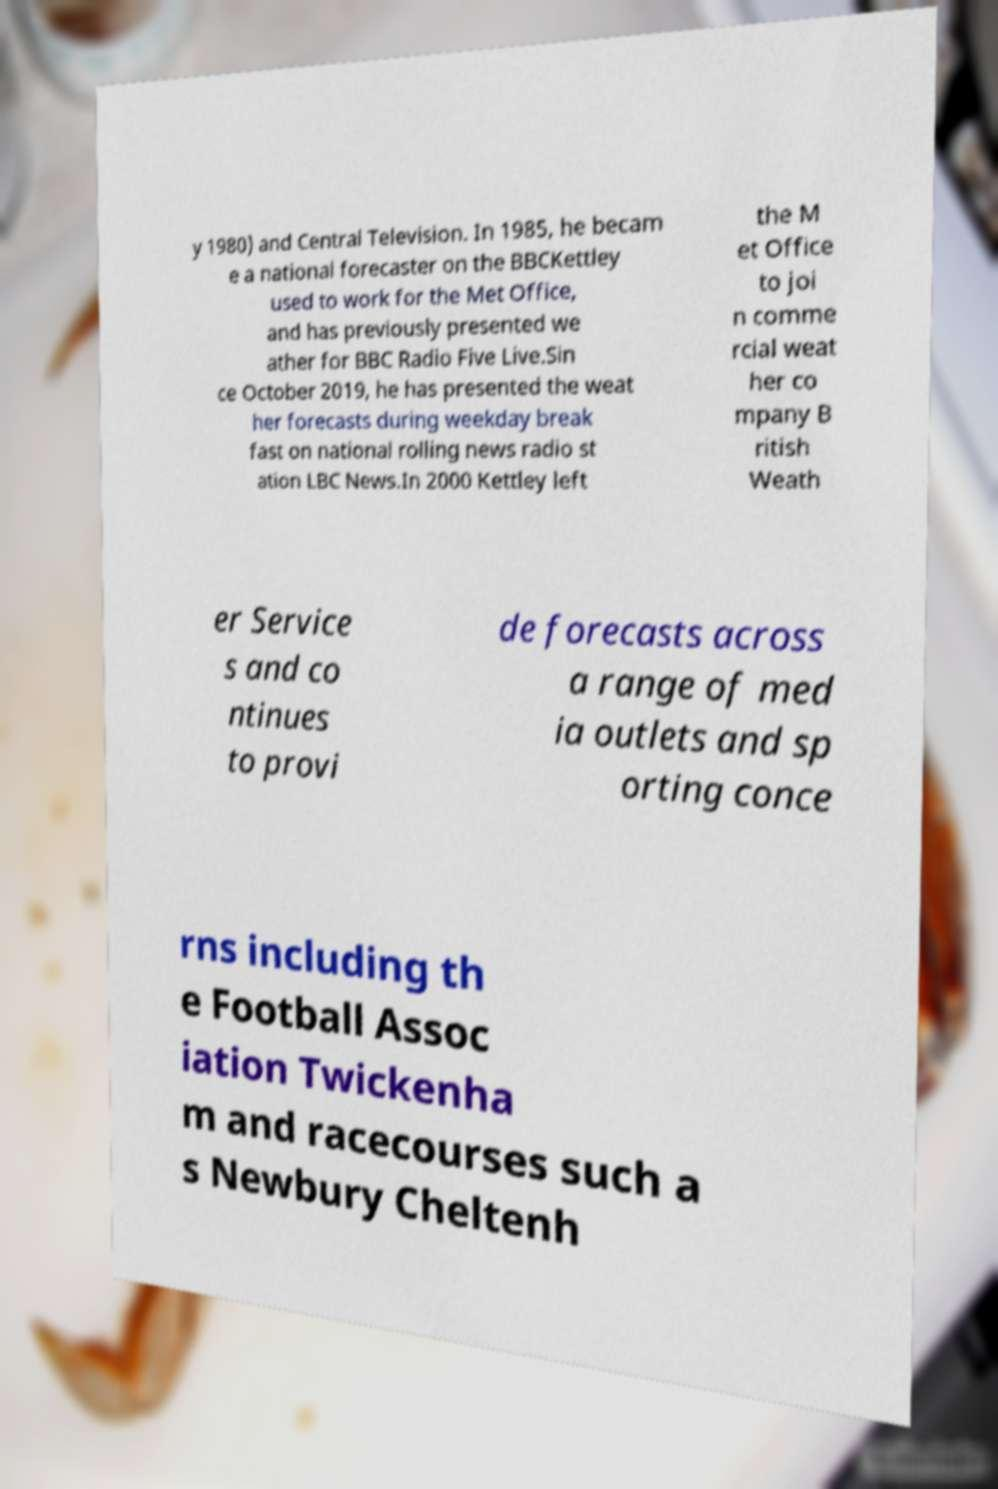Could you extract and type out the text from this image? y 1980) and Central Television. In 1985, he becam e a national forecaster on the BBCKettley used to work for the Met Office, and has previously presented we ather for BBC Radio Five Live.Sin ce October 2019, he has presented the weat her forecasts during weekday break fast on national rolling news radio st ation LBC News.In 2000 Kettley left the M et Office to joi n comme rcial weat her co mpany B ritish Weath er Service s and co ntinues to provi de forecasts across a range of med ia outlets and sp orting conce rns including th e Football Assoc iation Twickenha m and racecourses such a s Newbury Cheltenh 